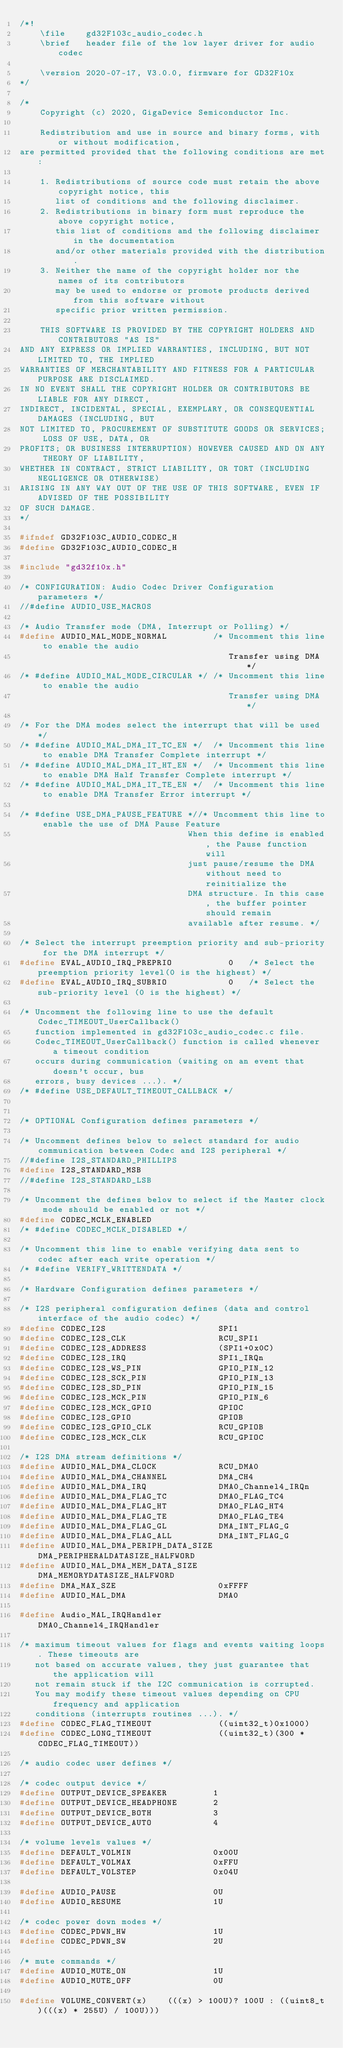Convert code to text. <code><loc_0><loc_0><loc_500><loc_500><_C_>/*!
    \file    gd32F103c_audio_codec.h
    \brief   header file of the low layer driver for audio codec

    \version 2020-07-17, V3.0.0, firmware for GD32F10x
*/

/*
    Copyright (c) 2020, GigaDevice Semiconductor Inc.

    Redistribution and use in source and binary forms, with or without modification, 
are permitted provided that the following conditions are met:

    1. Redistributions of source code must retain the above copyright notice, this 
       list of conditions and the following disclaimer.
    2. Redistributions in binary form must reproduce the above copyright notice, 
       this list of conditions and the following disclaimer in the documentation 
       and/or other materials provided with the distribution.
    3. Neither the name of the copyright holder nor the names of its contributors 
       may be used to endorse or promote products derived from this software without 
       specific prior written permission.

    THIS SOFTWARE IS PROVIDED BY THE COPYRIGHT HOLDERS AND CONTRIBUTORS "AS IS" 
AND ANY EXPRESS OR IMPLIED WARRANTIES, INCLUDING, BUT NOT LIMITED TO, THE IMPLIED 
WARRANTIES OF MERCHANTABILITY AND FITNESS FOR A PARTICULAR PURPOSE ARE DISCLAIMED. 
IN NO EVENT SHALL THE COPYRIGHT HOLDER OR CONTRIBUTORS BE LIABLE FOR ANY DIRECT, 
INDIRECT, INCIDENTAL, SPECIAL, EXEMPLARY, OR CONSEQUENTIAL DAMAGES (INCLUDING, BUT 
NOT LIMITED TO, PROCUREMENT OF SUBSTITUTE GOODS OR SERVICES; LOSS OF USE, DATA, OR 
PROFITS; OR BUSINESS INTERRUPTION) HOWEVER CAUSED AND ON ANY THEORY OF LIABILITY, 
WHETHER IN CONTRACT, STRICT LIABILITY, OR TORT (INCLUDING NEGLIGENCE OR OTHERWISE) 
ARISING IN ANY WAY OUT OF THE USE OF THIS SOFTWARE, EVEN IF ADVISED OF THE POSSIBILITY 
OF SUCH DAMAGE.
*/

#ifndef GD32F103C_AUDIO_CODEC_H
#define GD32F103C_AUDIO_CODEC_H

#include "gd32f10x.h"

/* CONFIGURATION: Audio Codec Driver Configuration parameters */
//#define AUDIO_USE_MACROS

/* Audio Transfer mode (DMA, Interrupt or Polling) */
#define AUDIO_MAL_MODE_NORMAL         /* Uncomment this line to enable the audio 
                                         Transfer using DMA */
/* #define AUDIO_MAL_MODE_CIRCULAR */ /* Uncomment this line to enable the audio 
                                         Transfer using DMA */

/* For the DMA modes select the interrupt that will be used */
/* #define AUDIO_MAL_DMA_IT_TC_EN */  /* Uncomment this line to enable DMA Transfer Complete interrupt */
/* #define AUDIO_MAL_DMA_IT_HT_EN */  /* Uncomment this line to enable DMA Half Transfer Complete interrupt */
/* #define AUDIO_MAL_DMA_IT_TE_EN */  /* Uncomment this line to enable DMA Transfer Error interrupt */

/* #define USE_DMA_PAUSE_FEATURE *//* Uncomment this line to enable the use of DMA Pause Feature
                                 When this define is enabled, the Pause function will
                                 just pause/resume the DMA without need to reinitialize the
                                 DMA structure. In this case, the buffer pointer should remain
                                 available after resume. */

/* Select the interrupt preemption priority and sub-priority for the DMA interrupt */
#define EVAL_AUDIO_IRQ_PREPRIO           0   /* Select the preemption priority level(0 is the highest) */
#define EVAL_AUDIO_IRQ_SUBRIO            0   /* Select the sub-priority level (0 is the highest) */

/* Uncomment the following line to use the default Codec_TIMEOUT_UserCallback() 
   function implemented in gd32F103c_audio_codec.c file.
   Codec_TIMEOUT_UserCallback() function is called whenever a timeout condition 
   occurs during communication (waiting on an event that doesn't occur, bus 
   errors, busy devices ...). */   
/* #define USE_DEFAULT_TIMEOUT_CALLBACK */


/* OPTIONAL Configuration defines parameters */

/* Uncomment defines below to select standard for audio communication between Codec and I2S peripheral */
//#define I2S_STANDARD_PHILLIPS
#define I2S_STANDARD_MSB
//#define I2S_STANDARD_LSB

/* Uncomment the defines below to select if the Master clock mode should be enabled or not */
#define CODEC_MCLK_ENABLED
/* #define CODEC_MCLK_DISABLED */

/* Uncomment this line to enable verifying data sent to codec after each write operation */
/* #define VERIFY_WRITTENDATA */

/* Hardware Configuration defines parameters */

/* I2S peripheral configuration defines (data and control interface of the audio codec) */
#define CODEC_I2S                      SPI1
#define CODEC_I2S_CLK                  RCU_SPI1
#define CODEC_I2S_ADDRESS              (SPI1+0x0C)
#define CODEC_I2S_IRQ                  SPI1_IRQn
#define CODEC_I2S_WS_PIN               GPIO_PIN_12
#define CODEC_I2S_SCK_PIN              GPIO_PIN_13
#define CODEC_I2S_SD_PIN               GPIO_PIN_15
#define CODEC_I2S_MCK_PIN              GPIO_PIN_6
#define CODEC_I2S_MCK_GPIO             GPIOC
#define CODEC_I2S_GPIO                 GPIOB
#define CODEC_I2S_GPIO_CLK             RCU_GPIOB
#define CODEC_I2S_MCK_CLK              RCU_GPIOC

/* I2S DMA stream definitions */
#define AUDIO_MAL_DMA_CLOCK            RCU_DMA0
#define AUDIO_MAL_DMA_CHANNEL          DMA_CH4
#define AUDIO_MAL_DMA_IRQ              DMA0_Channel4_IRQn
#define AUDIO_MAL_DMA_FLAG_TC          DMA0_FLAG_TC4
#define AUDIO_MAL_DMA_FLAG_HT          DMA0_FLAG_HT4
#define AUDIO_MAL_DMA_FLAG_TE          DMA0_FLAG_TE4
#define AUDIO_MAL_DMA_FLAG_GL          DMA_INT_FLAG_G
#define AUDIO_MAL_DMA_FLAG_ALL         DMA_INT_FLAG_G
#define AUDIO_MAL_DMA_PERIPH_DATA_SIZE DMA_PERIPHERALDATASIZE_HALFWORD
#define AUDIO_MAL_DMA_MEM_DATA_SIZE    DMA_MEMORYDATASIZE_HALFWORD
#define DMA_MAX_SZE                    0xFFFF
#define AUDIO_MAL_DMA                  DMA0

#define Audio_MAL_IRQHandler           DMA0_Channel4_IRQHandler

/* maximum timeout values for flags and events waiting loops. These timeouts are
   not based on accurate values, they just guarantee that the application will 
   not remain stuck if the I2C communication is corrupted.
   You may modify these timeout values depending on CPU frequency and application
   conditions (interrupts routines ...). */   
#define CODEC_FLAG_TIMEOUT             ((uint32_t)0x1000)
#define CODEC_LONG_TIMEOUT             ((uint32_t)(300 * CODEC_FLAG_TIMEOUT))

/* audio codec user defines */

/* codec output device */
#define OUTPUT_DEVICE_SPEAKER         1
#define OUTPUT_DEVICE_HEADPHONE       2
#define OUTPUT_DEVICE_BOTH            3
#define OUTPUT_DEVICE_AUTO            4

/* volume levels values */
#define DEFAULT_VOLMIN                0x00U
#define DEFAULT_VOLMAX                0xFFU
#define DEFAULT_VOLSTEP               0x04U

#define AUDIO_PAUSE                   0U
#define AUDIO_RESUME                  1U

/* codec power down modes */
#define CODEC_PDWN_HW                 1U
#define CODEC_PDWN_SW                 2U

/* mute commands */
#define AUDIO_MUTE_ON                 1U
#define AUDIO_MUTE_OFF                0U

#define VOLUME_CONVERT(x)    (((x) > 100U)? 100U : ((uint8_t)(((x) * 255U) / 100U)))</code> 